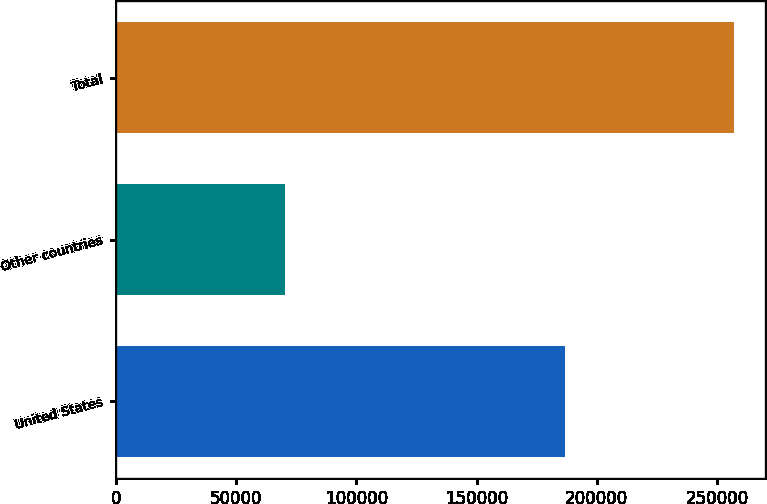<chart> <loc_0><loc_0><loc_500><loc_500><bar_chart><fcel>United States<fcel>Other countries<fcel>Total<nl><fcel>186854<fcel>70181<fcel>257035<nl></chart> 